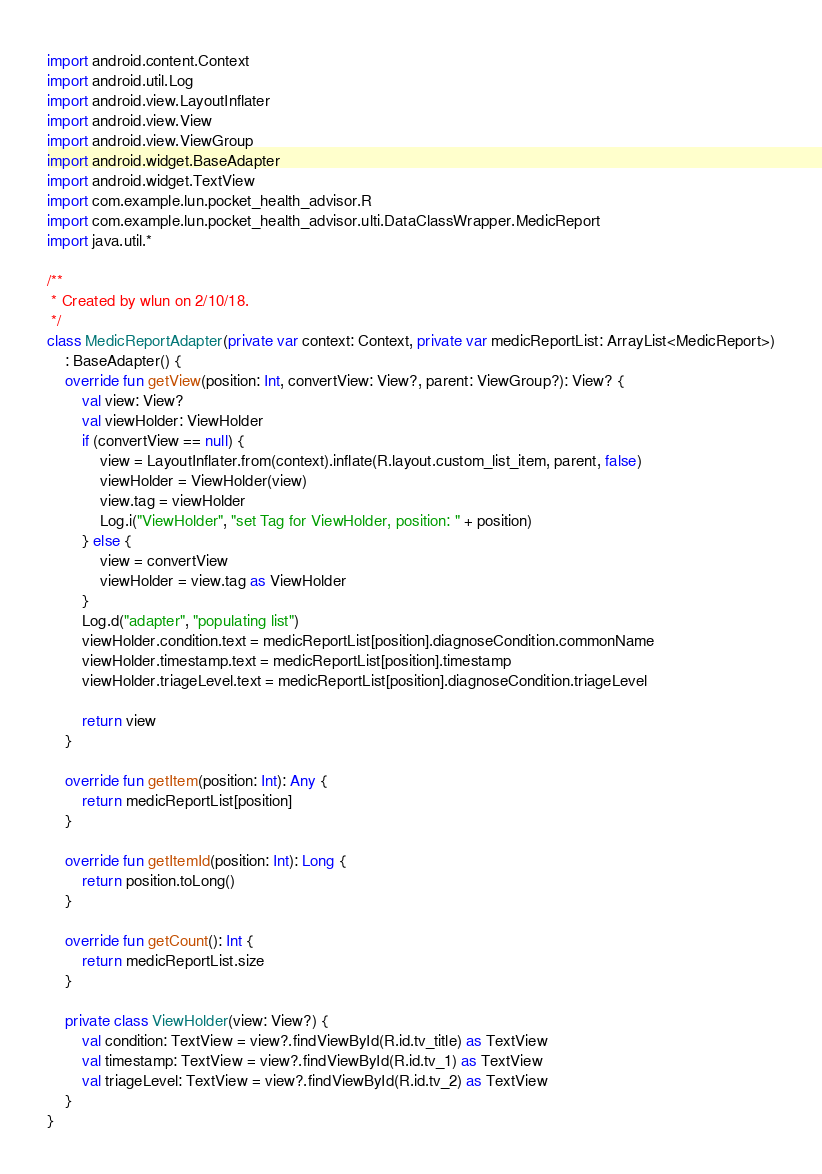Convert code to text. <code><loc_0><loc_0><loc_500><loc_500><_Kotlin_>import android.content.Context
import android.util.Log
import android.view.LayoutInflater
import android.view.View
import android.view.ViewGroup
import android.widget.BaseAdapter
import android.widget.TextView
import com.example.lun.pocket_health_advisor.R
import com.example.lun.pocket_health_advisor.ulti.DataClassWrapper.MedicReport
import java.util.*

/**
 * Created by wlun on 2/10/18.
 */
class MedicReportAdapter(private var context: Context, private var medicReportList: ArrayList<MedicReport>)
    : BaseAdapter() {
    override fun getView(position: Int, convertView: View?, parent: ViewGroup?): View? {
        val view: View?
        val viewHolder: ViewHolder
        if (convertView == null) {
            view = LayoutInflater.from(context).inflate(R.layout.custom_list_item, parent, false)
            viewHolder = ViewHolder(view)
            view.tag = viewHolder
            Log.i("ViewHolder", "set Tag for ViewHolder, position: " + position)
        } else {
            view = convertView
            viewHolder = view.tag as ViewHolder
        }
        Log.d("adapter", "populating list")
        viewHolder.condition.text = medicReportList[position].diagnoseCondition.commonName
        viewHolder.timestamp.text = medicReportList[position].timestamp
        viewHolder.triageLevel.text = medicReportList[position].diagnoseCondition.triageLevel

        return view
    }

    override fun getItem(position: Int): Any {
        return medicReportList[position]
    }

    override fun getItemId(position: Int): Long {
        return position.toLong()
    }

    override fun getCount(): Int {
        return medicReportList.size
    }

    private class ViewHolder(view: View?) {
        val condition: TextView = view?.findViewById(R.id.tv_title) as TextView
        val timestamp: TextView = view?.findViewById(R.id.tv_1) as TextView
        val triageLevel: TextView = view?.findViewById(R.id.tv_2) as TextView
    }
}</code> 